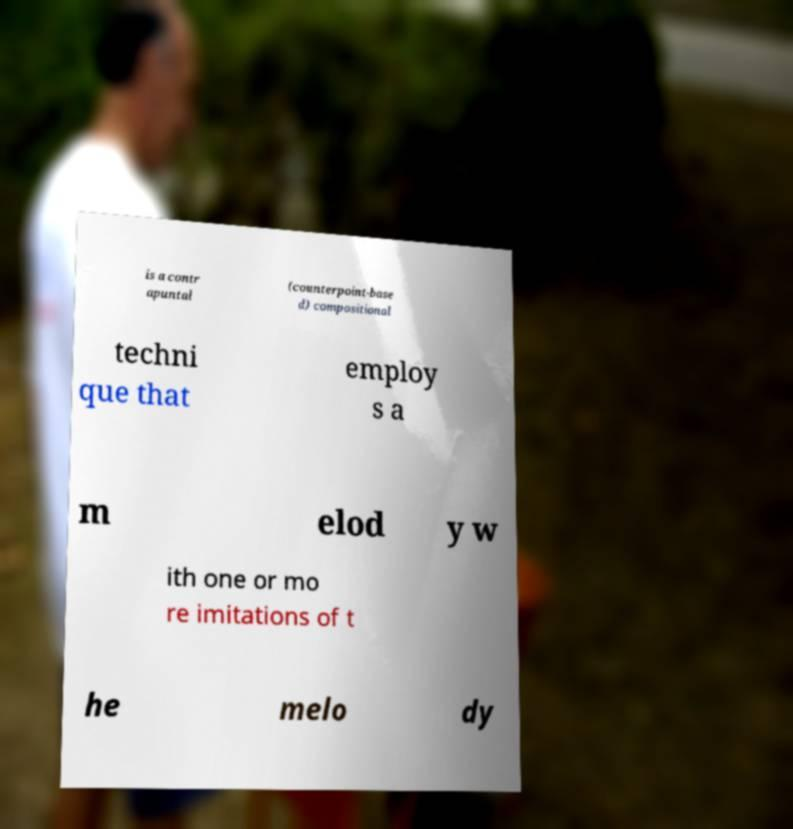Can you accurately transcribe the text from the provided image for me? is a contr apuntal (counterpoint-base d) compositional techni que that employ s a m elod y w ith one or mo re imitations of t he melo dy 